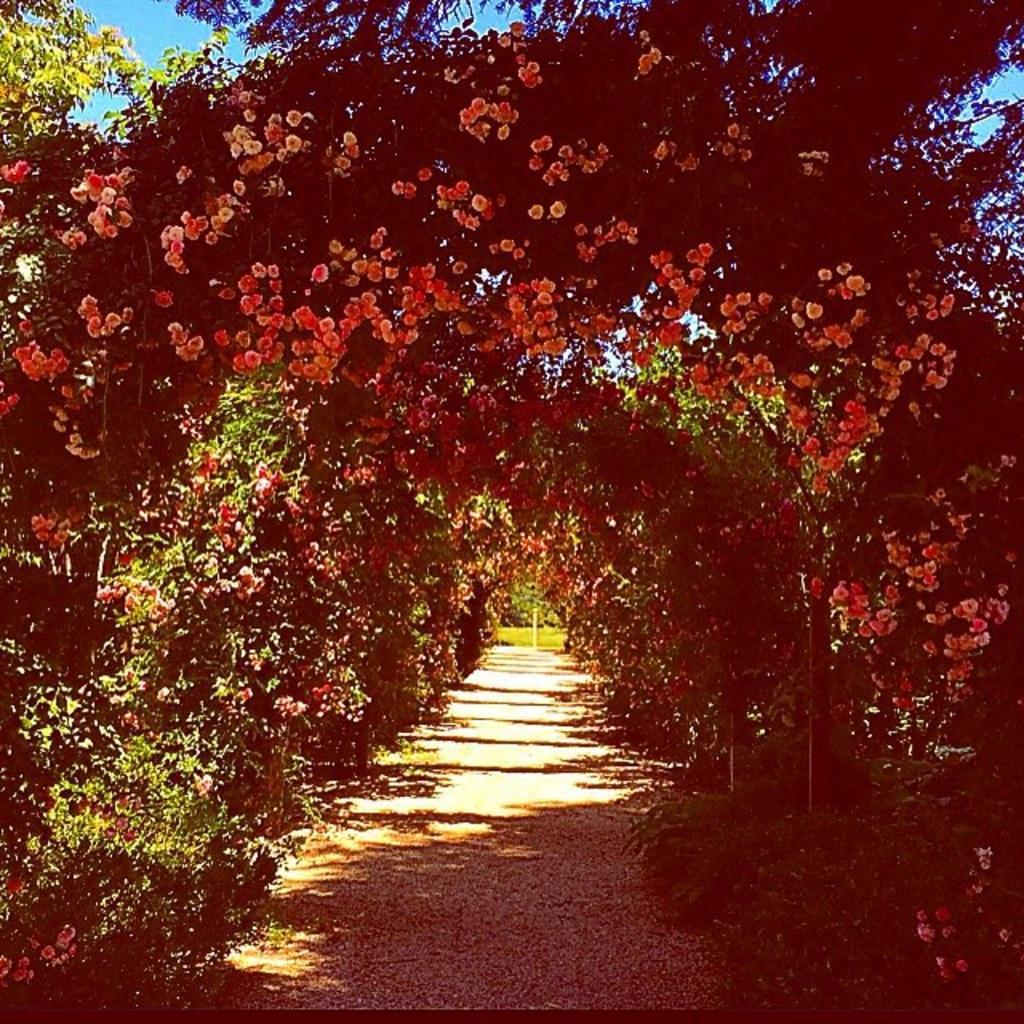Describe this image in one or two sentences. In this image I can see a garden and I can see plants and flowers and at the top I can see the sky. 